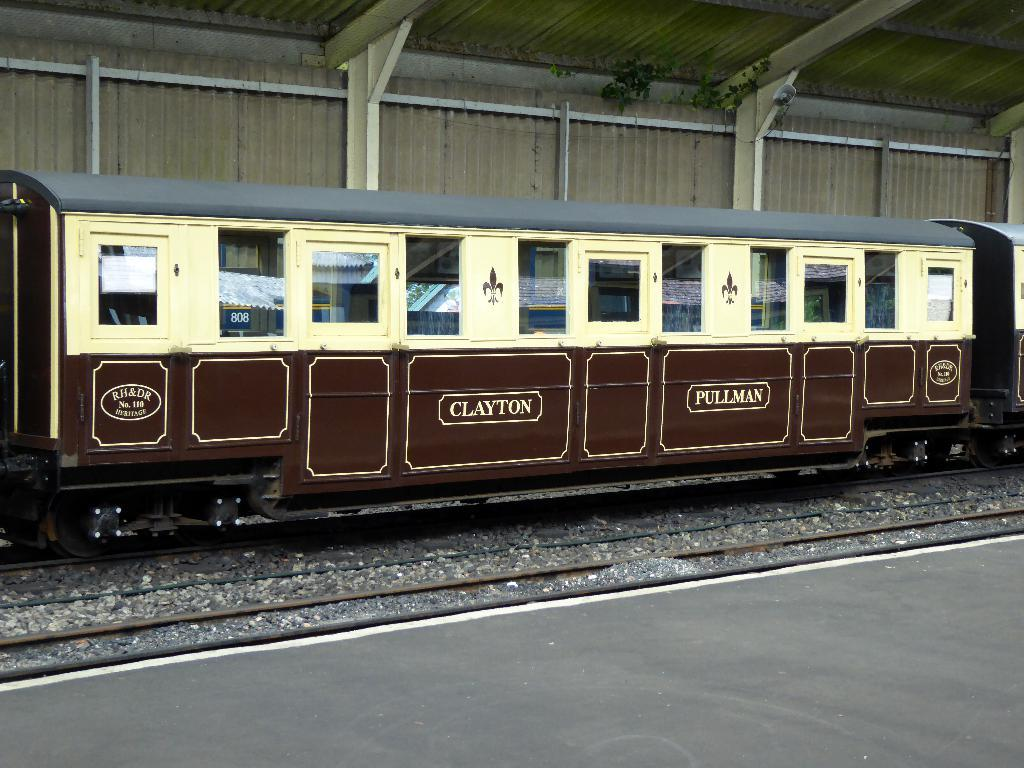How many railway coaches are visible in the image? There are two railway coaches in the image. Where are the railway coaches located? The railway coaches are on a railway track. What else can be seen in the image besides the railway coaches? There is a platform in the image. How many horses are visible on the platform in the image? There are no horses present in the image; it only features railway coaches and a platform. What type of club is being used by the passengers in the railway coaches? There is no club visible in the image, as it only features railway coaches and a platform. 